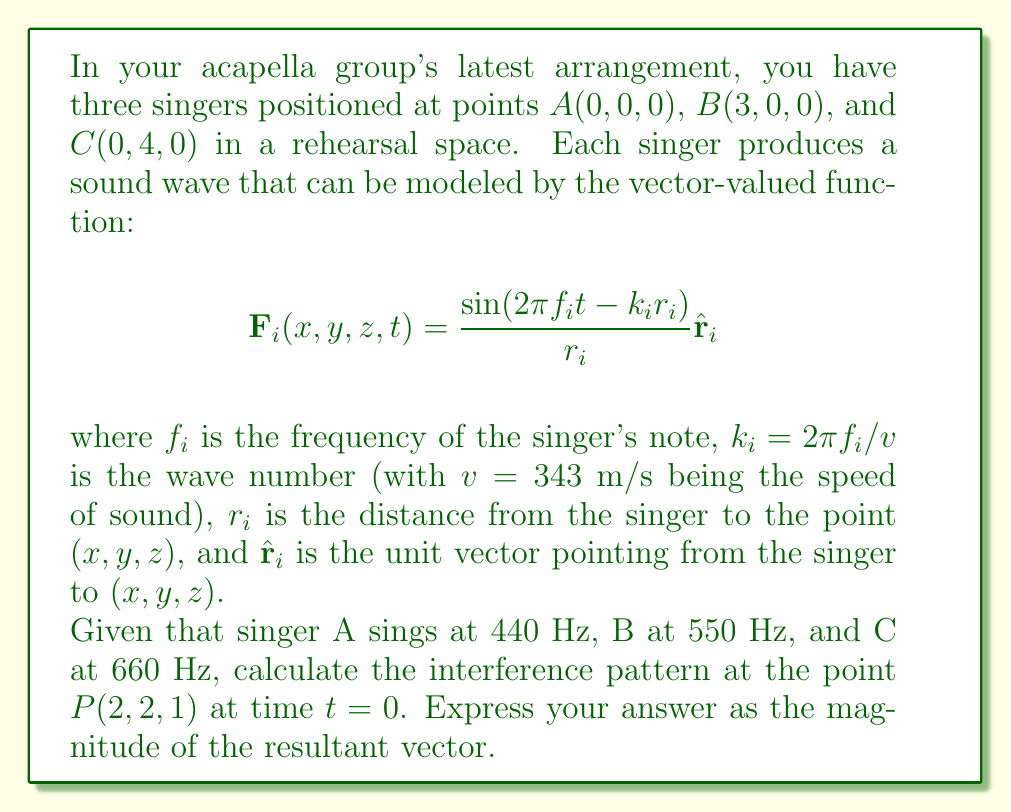Help me with this question. Let's approach this step-by-step:

1) First, we need to calculate $r_i$ for each singer:

   $r_A = \sqrt{(2-0)^2 + (2-0)^2 + (1-0)^2} = 3$
   $r_B = \sqrt{(2-3)^2 + (2-0)^2 + (1-0)^2} = \sqrt{6}$
   $r_C = \sqrt{(2-0)^2 + (2-4)^2 + (1-0)^2} = 3$

2) Next, calculate $k_i$ for each singer:

   $k_A = 2\pi(440)/343 \approx 8.05$
   $k_B = 2\pi(550)/343 \approx 10.06$
   $k_C = 2\pi(660)/343 \approx 12.08$

3) Now, we can calculate the unit vectors $\hat{\mathbf{r}}_i$:

   $\hat{\mathbf{r}}_A = (2/3)\hat{\mathbf{i}} + (2/3)\hat{\mathbf{j}} + (1/3)\hat{\mathbf{k}}$
   $\hat{\mathbf{r}}_B = (-1/\sqrt{6})\hat{\mathbf{i}} + (\sqrt{2}/\sqrt{3})\hat{\mathbf{j}} + (1/\sqrt{6})\hat{\mathbf{k}}$
   $\hat{\mathbf{r}}_C = (2/3)\hat{\mathbf{i}} + (-2/3)\hat{\mathbf{j}} + (1/3)\hat{\mathbf{k}}$

4) Now we can calculate each $\mathbf{F}_i$ at $t=0$:

   $\mathbf{F}_A = \frac{\sin(-8.05 \cdot 3)}{3} \cdot \hat{\mathbf{r}}_A$
   $\mathbf{F}_B = \frac{\sin(-10.06 \cdot \sqrt{6})}{\sqrt{6}} \cdot \hat{\mathbf{r}}_B$
   $\mathbf{F}_C = \frac{\sin(-12.08 \cdot 3)}{3} \cdot \hat{\mathbf{r}}_C$

5) Calculate the numerical values:

   $\mathbf{F}_A \approx (-0.0877, -0.0877, -0.0439)$
   $\mathbf{F}_B \approx (0.1501, -0.3001, 0.1501)$
   $\mathbf{F}_C \approx (-0.2199, 0.2199, -0.1100)$

6) Sum these vectors:

   $\mathbf{F}_{total} = \mathbf{F}_A + \mathbf{F}_B + \mathbf{F}_C$
   $\mathbf{F}_{total} \approx (-0.1575, -0.1679, -0.0038)$

7) Calculate the magnitude of the resultant vector:

   $|\mathbf{F}_{total}| = \sqrt{(-0.1575)^2 + (-0.1679)^2 + (-0.0038)^2} \approx 0.2304$
Answer: The magnitude of the interference pattern at point $P(2,2,1)$ at time $t=0$ is approximately $0.2304$. 